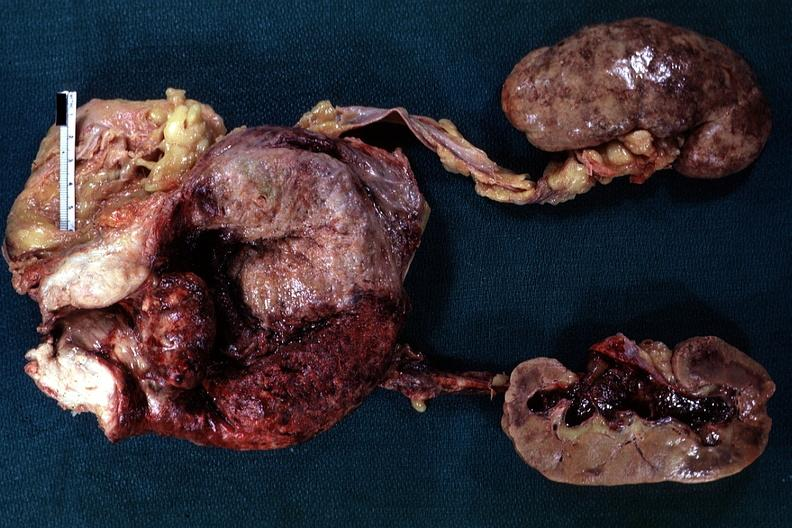s prostate present?
Answer the question using a single word or phrase. Yes 